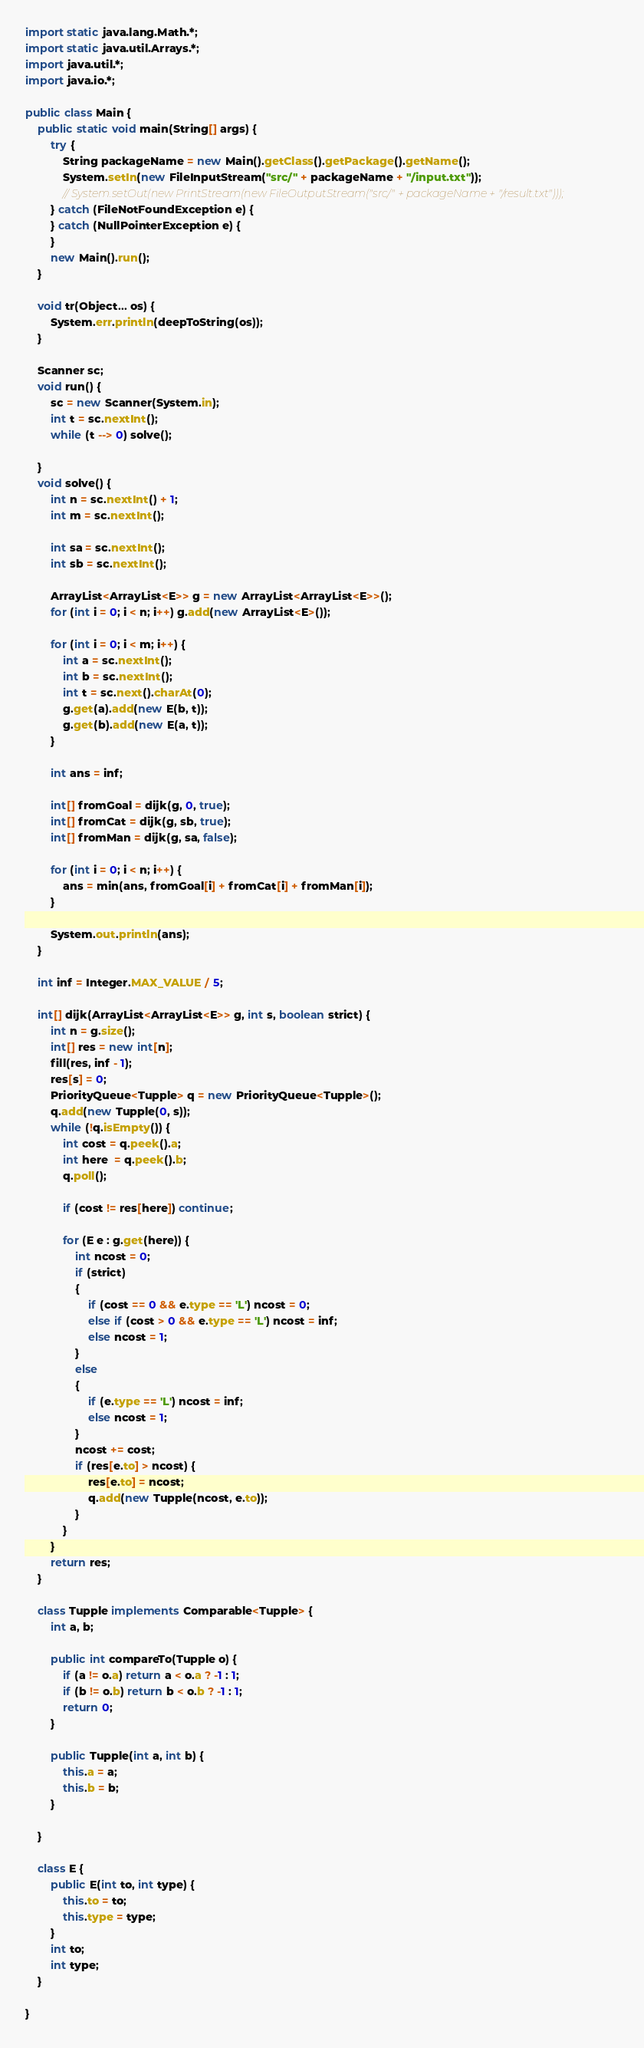<code> <loc_0><loc_0><loc_500><loc_500><_Java_>import static java.lang.Math.*;
import static java.util.Arrays.*;
import java.util.*;
import java.io.*;

public class Main {
	public static void main(String[] args) {
		try {
			String packageName = new Main().getClass().getPackage().getName();
			System.setIn(new FileInputStream("src/" + packageName + "/input.txt"));
			// System.setOut(new PrintStream(new FileOutputStream("src/" + packageName + "/result.txt")));
		} catch (FileNotFoundException e) {
		} catch (NullPointerException e) {
		}
		new Main().run();
	}

	void tr(Object... os) {
		System.err.println(deepToString(os));
	}

	Scanner sc;
	void run() {
		sc = new Scanner(System.in);
		int t = sc.nextInt();
		while (t --> 0) solve();

	}
	void solve() {
		int n = sc.nextInt() + 1;
		int m = sc.nextInt();

		int sa = sc.nextInt();
		int sb = sc.nextInt();

		ArrayList<ArrayList<E>> g = new ArrayList<ArrayList<E>>();
		for (int i = 0; i < n; i++) g.add(new ArrayList<E>());

		for (int i = 0; i < m; i++) {
			int a = sc.nextInt();
			int b = sc.nextInt();
			int t = sc.next().charAt(0);
			g.get(a).add(new E(b, t));
			g.get(b).add(new E(a, t));
		}

		int ans = inf;

		int[] fromGoal = dijk(g, 0, true);
		int[] fromCat = dijk(g, sb, true);
		int[] fromMan = dijk(g, sa, false);

		for (int i = 0; i < n; i++) {
			ans = min(ans, fromGoal[i] + fromCat[i] + fromMan[i]);
		}

		System.out.println(ans);
	}

	int inf = Integer.MAX_VALUE / 5;

	int[] dijk(ArrayList<ArrayList<E>> g, int s, boolean strict) {
		int n = g.size();
		int[] res = new int[n];
		fill(res, inf - 1);
		res[s] = 0;
		PriorityQueue<Tupple> q = new PriorityQueue<Tupple>();
		q.add(new Tupple(0, s));
		while (!q.isEmpty()) {
			int cost = q.peek().a;
			int here  = q.peek().b;
			q.poll();

			if (cost != res[here]) continue;

			for (E e : g.get(here)) {
				int ncost = 0;
				if (strict)
				{
					if (cost == 0 && e.type == 'L') ncost = 0;
					else if (cost > 0 && e.type == 'L') ncost = inf;
					else ncost = 1;
				}
				else
				{
					if (e.type == 'L') ncost = inf;
					else ncost = 1;
				}
				ncost += cost;
				if (res[e.to] > ncost) {
					res[e.to] = ncost;
					q.add(new Tupple(ncost, e.to));
				}
			}
		}
		return res;
	}

	class Tupple implements Comparable<Tupple> {
		int a, b;

		public int compareTo(Tupple o) {
			if (a != o.a) return a < o.a ? -1 : 1;
			if (b != o.b) return b < o.b ? -1 : 1;
			return 0;
		}

		public Tupple(int a, int b) {
			this.a = a;
			this.b = b;
		}

	}

	class E {
		public E(int to, int type) {
			this.to = to;
			this.type = type;
		}
		int to;
		int type;
	}

}</code> 